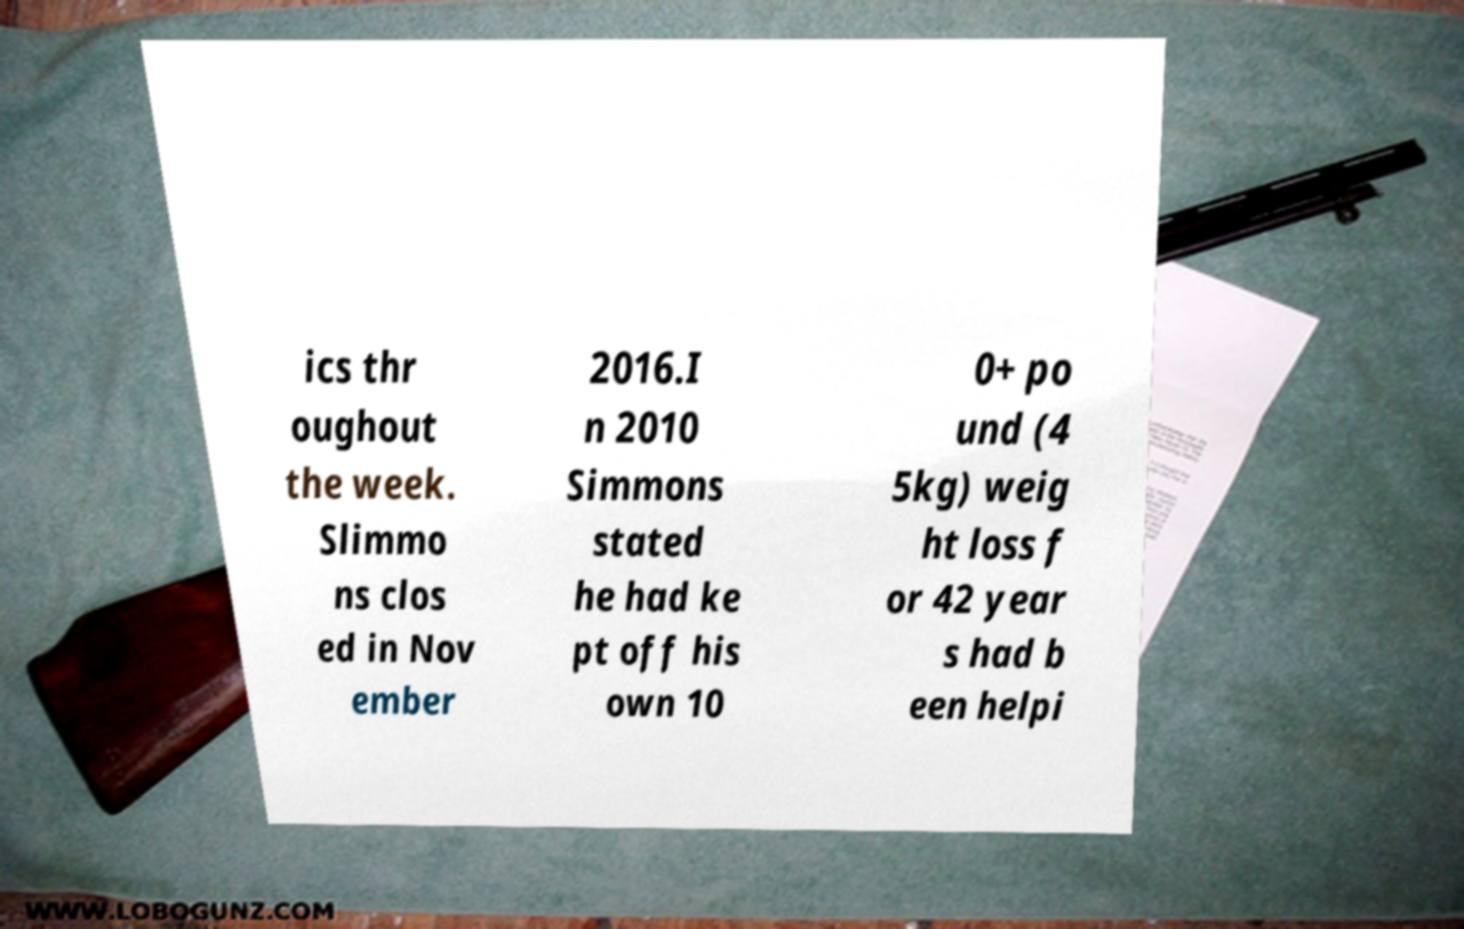Could you assist in decoding the text presented in this image and type it out clearly? ics thr oughout the week. Slimmo ns clos ed in Nov ember 2016.I n 2010 Simmons stated he had ke pt off his own 10 0+ po und (4 5kg) weig ht loss f or 42 year s had b een helpi 